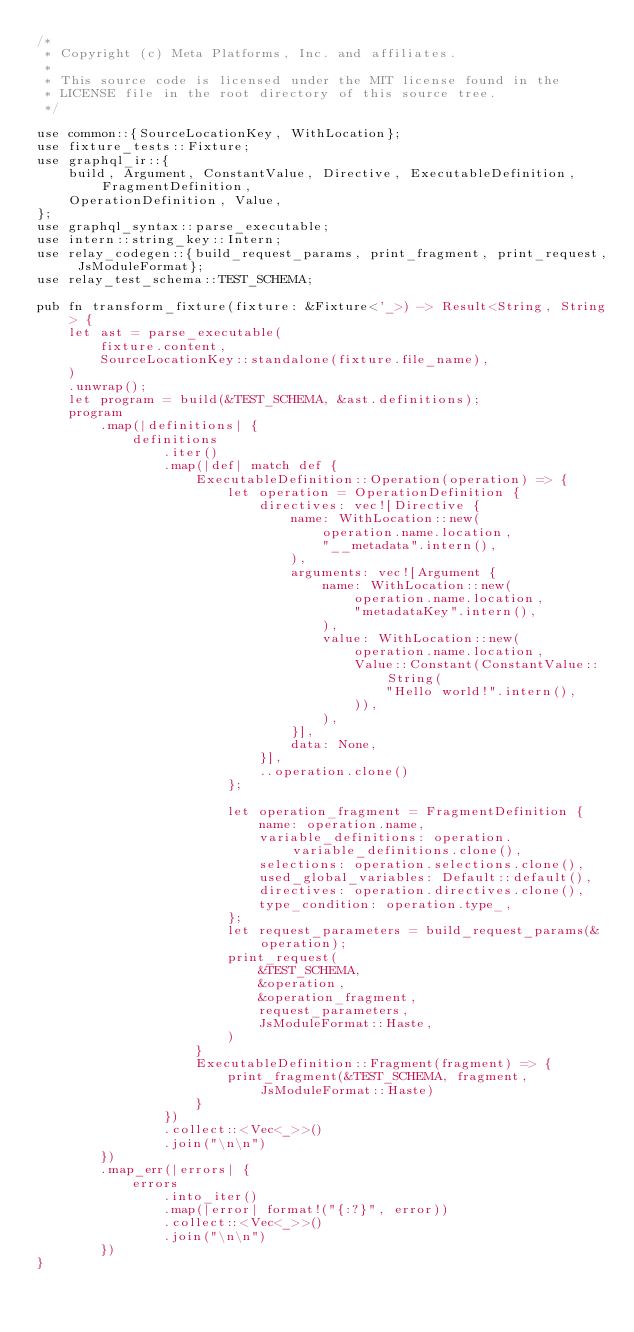Convert code to text. <code><loc_0><loc_0><loc_500><loc_500><_Rust_>/*
 * Copyright (c) Meta Platforms, Inc. and affiliates.
 *
 * This source code is licensed under the MIT license found in the
 * LICENSE file in the root directory of this source tree.
 */

use common::{SourceLocationKey, WithLocation};
use fixture_tests::Fixture;
use graphql_ir::{
    build, Argument, ConstantValue, Directive, ExecutableDefinition, FragmentDefinition,
    OperationDefinition, Value,
};
use graphql_syntax::parse_executable;
use intern::string_key::Intern;
use relay_codegen::{build_request_params, print_fragment, print_request, JsModuleFormat};
use relay_test_schema::TEST_SCHEMA;

pub fn transform_fixture(fixture: &Fixture<'_>) -> Result<String, String> {
    let ast = parse_executable(
        fixture.content,
        SourceLocationKey::standalone(fixture.file_name),
    )
    .unwrap();
    let program = build(&TEST_SCHEMA, &ast.definitions);
    program
        .map(|definitions| {
            definitions
                .iter()
                .map(|def| match def {
                    ExecutableDefinition::Operation(operation) => {
                        let operation = OperationDefinition {
                            directives: vec![Directive {
                                name: WithLocation::new(
                                    operation.name.location,
                                    "__metadata".intern(),
                                ),
                                arguments: vec![Argument {
                                    name: WithLocation::new(
                                        operation.name.location,
                                        "metadataKey".intern(),
                                    ),
                                    value: WithLocation::new(
                                        operation.name.location,
                                        Value::Constant(ConstantValue::String(
                                            "Hello world!".intern(),
                                        )),
                                    ),
                                }],
                                data: None,
                            }],
                            ..operation.clone()
                        };

                        let operation_fragment = FragmentDefinition {
                            name: operation.name,
                            variable_definitions: operation.variable_definitions.clone(),
                            selections: operation.selections.clone(),
                            used_global_variables: Default::default(),
                            directives: operation.directives.clone(),
                            type_condition: operation.type_,
                        };
                        let request_parameters = build_request_params(&operation);
                        print_request(
                            &TEST_SCHEMA,
                            &operation,
                            &operation_fragment,
                            request_parameters,
                            JsModuleFormat::Haste,
                        )
                    }
                    ExecutableDefinition::Fragment(fragment) => {
                        print_fragment(&TEST_SCHEMA, fragment, JsModuleFormat::Haste)
                    }
                })
                .collect::<Vec<_>>()
                .join("\n\n")
        })
        .map_err(|errors| {
            errors
                .into_iter()
                .map(|error| format!("{:?}", error))
                .collect::<Vec<_>>()
                .join("\n\n")
        })
}
</code> 